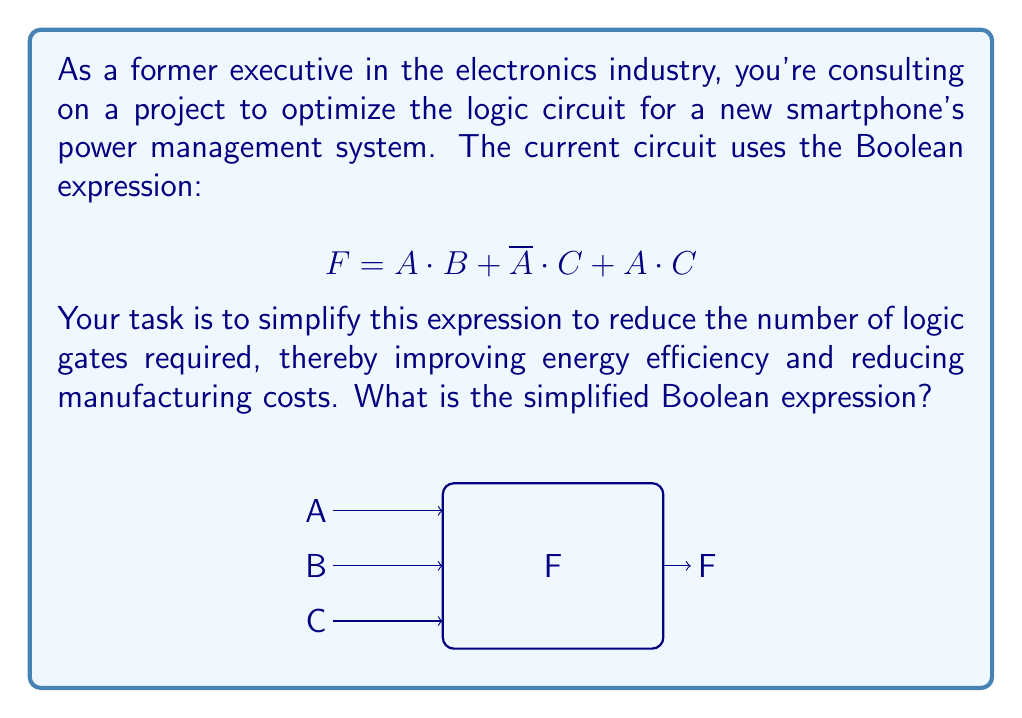Could you help me with this problem? Let's simplify this Boolean expression step by step using Boolean algebra laws:

1) Start with the original expression:
   $$ F = A \cdot B + \overline{A} \cdot C + A \cdot C $$

2) Factor out C from the last two terms:
   $$ F = A \cdot B + C \cdot (\overline{A} + A) $$

3) Simplify $(\overline{A} + A)$ using the complement law:
   $$ F = A \cdot B + C \cdot 1 $$

4) Simplify further:
   $$ F = A \cdot B + C $$

5) This is our final simplified expression. It uses fewer operations than the original, which means fewer logic gates in the circuit.

To verify, we can create a truth table for both expressions and confirm they produce the same output for all input combinations.

This simplification reduces the circuit from using two AND gates and two OR gates to using just one AND gate and one OR gate, significantly optimizing the power management system's efficiency and reducing manufacturing costs.
Answer: $$ F = A \cdot B + C $$ 